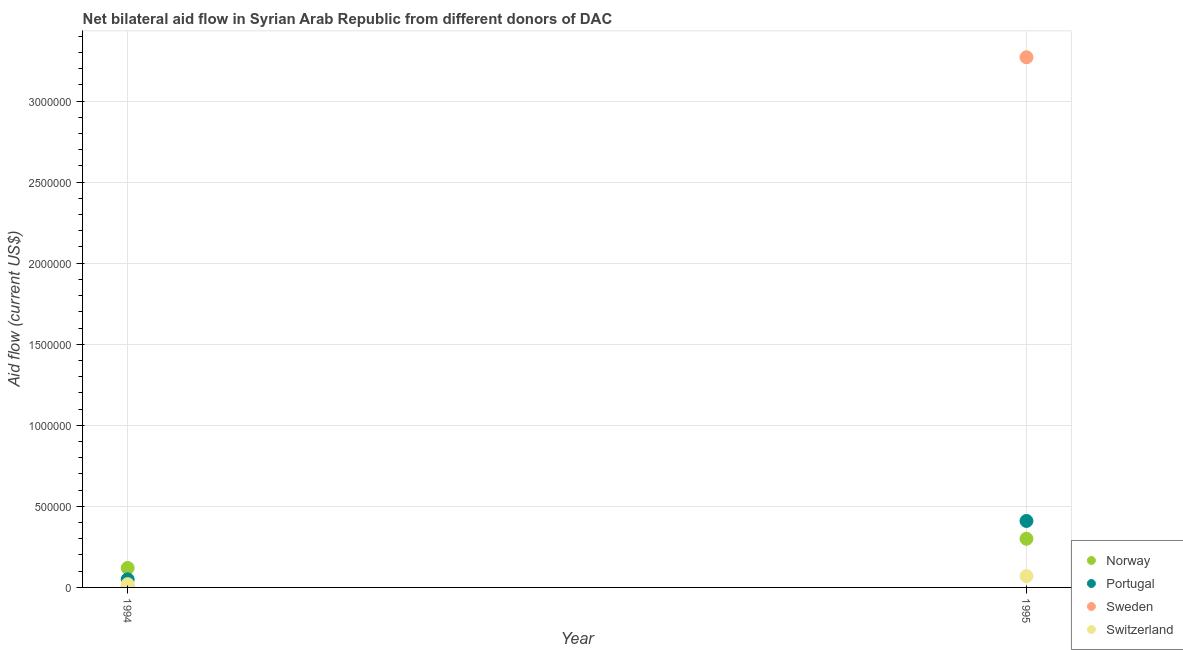How many different coloured dotlines are there?
Ensure brevity in your answer.  4. What is the amount of aid given by sweden in 1995?
Your answer should be very brief. 3.27e+06. Across all years, what is the maximum amount of aid given by norway?
Your answer should be compact. 3.00e+05. Across all years, what is the minimum amount of aid given by switzerland?
Ensure brevity in your answer.  2.00e+04. What is the total amount of aid given by norway in the graph?
Offer a very short reply. 4.20e+05. What is the difference between the amount of aid given by norway in 1994 and that in 1995?
Make the answer very short. -1.80e+05. What is the difference between the amount of aid given by norway in 1994 and the amount of aid given by switzerland in 1995?
Keep it short and to the point. 5.00e+04. What is the average amount of aid given by sweden per year?
Your answer should be compact. 1.64e+06. In the year 1995, what is the difference between the amount of aid given by norway and amount of aid given by sweden?
Offer a terse response. -2.97e+06. What is the ratio of the amount of aid given by norway in 1994 to that in 1995?
Offer a terse response. 0.4. In how many years, is the amount of aid given by sweden greater than the average amount of aid given by sweden taken over all years?
Provide a short and direct response. 1. Is it the case that in every year, the sum of the amount of aid given by portugal and amount of aid given by norway is greater than the sum of amount of aid given by sweden and amount of aid given by switzerland?
Offer a very short reply. Yes. Is the amount of aid given by sweden strictly greater than the amount of aid given by switzerland over the years?
Give a very brief answer. No. Is the amount of aid given by sweden strictly less than the amount of aid given by portugal over the years?
Keep it short and to the point. No. Are the values on the major ticks of Y-axis written in scientific E-notation?
Your response must be concise. No. Does the graph contain grids?
Provide a succinct answer. Yes. What is the title of the graph?
Make the answer very short. Net bilateral aid flow in Syrian Arab Republic from different donors of DAC. What is the Aid flow (current US$) in Norway in 1995?
Offer a very short reply. 3.00e+05. What is the Aid flow (current US$) in Sweden in 1995?
Keep it short and to the point. 3.27e+06. Across all years, what is the maximum Aid flow (current US$) in Norway?
Your answer should be very brief. 3.00e+05. Across all years, what is the maximum Aid flow (current US$) in Sweden?
Make the answer very short. 3.27e+06. Across all years, what is the maximum Aid flow (current US$) in Switzerland?
Make the answer very short. 7.00e+04. What is the total Aid flow (current US$) of Sweden in the graph?
Provide a short and direct response. 3.28e+06. What is the difference between the Aid flow (current US$) in Portugal in 1994 and that in 1995?
Your answer should be compact. -3.60e+05. What is the difference between the Aid flow (current US$) in Sweden in 1994 and that in 1995?
Provide a succinct answer. -3.26e+06. What is the difference between the Aid flow (current US$) in Switzerland in 1994 and that in 1995?
Make the answer very short. -5.00e+04. What is the difference between the Aid flow (current US$) in Norway in 1994 and the Aid flow (current US$) in Sweden in 1995?
Your response must be concise. -3.15e+06. What is the difference between the Aid flow (current US$) of Portugal in 1994 and the Aid flow (current US$) of Sweden in 1995?
Ensure brevity in your answer.  -3.22e+06. What is the difference between the Aid flow (current US$) of Sweden in 1994 and the Aid flow (current US$) of Switzerland in 1995?
Your response must be concise. -6.00e+04. What is the average Aid flow (current US$) in Norway per year?
Make the answer very short. 2.10e+05. What is the average Aid flow (current US$) of Portugal per year?
Your answer should be compact. 2.30e+05. What is the average Aid flow (current US$) in Sweden per year?
Provide a succinct answer. 1.64e+06. What is the average Aid flow (current US$) in Switzerland per year?
Give a very brief answer. 4.50e+04. In the year 1994, what is the difference between the Aid flow (current US$) of Norway and Aid flow (current US$) of Portugal?
Your answer should be very brief. 7.00e+04. In the year 1994, what is the difference between the Aid flow (current US$) in Norway and Aid flow (current US$) in Sweden?
Provide a short and direct response. 1.10e+05. In the year 1994, what is the difference between the Aid flow (current US$) in Norway and Aid flow (current US$) in Switzerland?
Your answer should be very brief. 1.00e+05. In the year 1994, what is the difference between the Aid flow (current US$) in Portugal and Aid flow (current US$) in Switzerland?
Your answer should be very brief. 3.00e+04. In the year 1994, what is the difference between the Aid flow (current US$) in Sweden and Aid flow (current US$) in Switzerland?
Give a very brief answer. -10000. In the year 1995, what is the difference between the Aid flow (current US$) of Norway and Aid flow (current US$) of Portugal?
Keep it short and to the point. -1.10e+05. In the year 1995, what is the difference between the Aid flow (current US$) of Norway and Aid flow (current US$) of Sweden?
Provide a succinct answer. -2.97e+06. In the year 1995, what is the difference between the Aid flow (current US$) of Norway and Aid flow (current US$) of Switzerland?
Your answer should be compact. 2.30e+05. In the year 1995, what is the difference between the Aid flow (current US$) of Portugal and Aid flow (current US$) of Sweden?
Your answer should be compact. -2.86e+06. In the year 1995, what is the difference between the Aid flow (current US$) in Sweden and Aid flow (current US$) in Switzerland?
Offer a very short reply. 3.20e+06. What is the ratio of the Aid flow (current US$) of Portugal in 1994 to that in 1995?
Your answer should be compact. 0.12. What is the ratio of the Aid flow (current US$) of Sweden in 1994 to that in 1995?
Offer a terse response. 0. What is the ratio of the Aid flow (current US$) of Switzerland in 1994 to that in 1995?
Provide a succinct answer. 0.29. What is the difference between the highest and the second highest Aid flow (current US$) in Portugal?
Keep it short and to the point. 3.60e+05. What is the difference between the highest and the second highest Aid flow (current US$) in Sweden?
Give a very brief answer. 3.26e+06. What is the difference between the highest and the second highest Aid flow (current US$) in Switzerland?
Keep it short and to the point. 5.00e+04. What is the difference between the highest and the lowest Aid flow (current US$) of Norway?
Your answer should be compact. 1.80e+05. What is the difference between the highest and the lowest Aid flow (current US$) in Portugal?
Your answer should be compact. 3.60e+05. What is the difference between the highest and the lowest Aid flow (current US$) in Sweden?
Provide a short and direct response. 3.26e+06. 